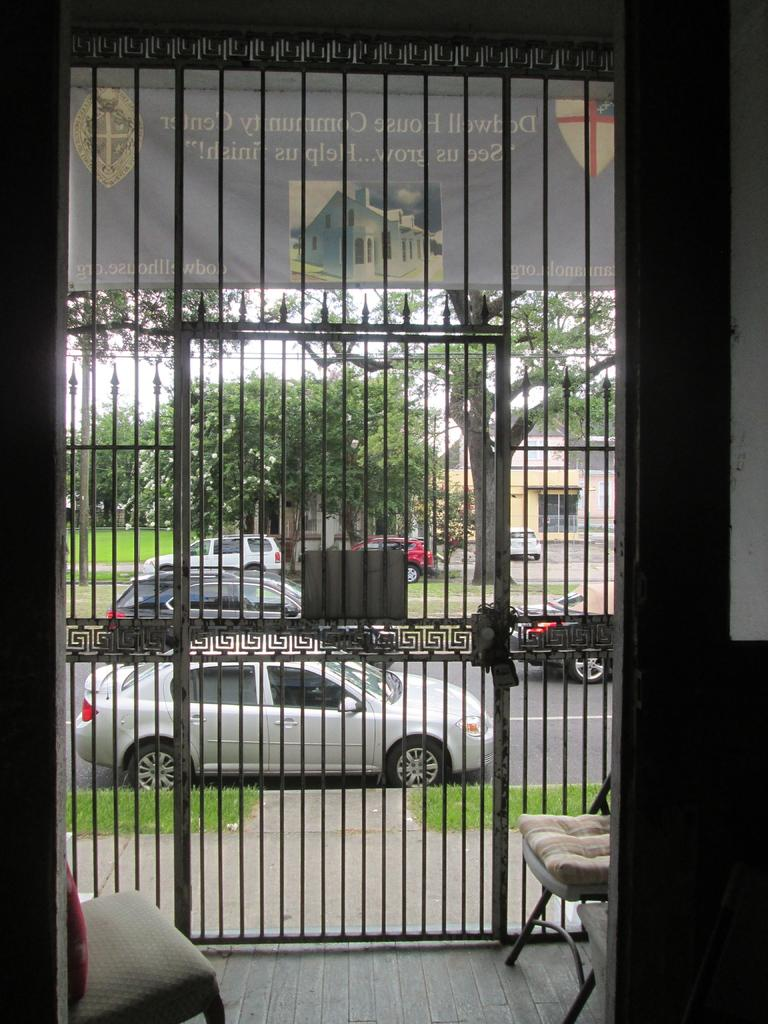What type of furniture can be seen on the floor in the image? There are chairs on the floor in the image. What structure is present in the image that might control access? There is a gate in the image. What type of signage is visible in the image? There is a banner in the image. What type of transportation can be seen in the image? There are vehicles on the road in the image. What type of natural vegetation is present in the image? There is grass and trees in the image. What type of building is present in the image? There is a shed in the image. Can you describe any unspecified objects in the image? There are some unspecified objects in the image. What can be seen in the background of the image? The sky is visible in the background of the image. Can you tell me how many friends are visible in the image? There is no mention of friends in the image; it features chairs, a gate, a banner, vehicles, grass, trees, a shed, and some unspecified objects. Was there an earthquake in the area depicted in the image? There is no indication of an earthquake in the image; it shows a relatively calm scene with chairs, a gate, a banner, vehicles, grass, trees, a shed, and some unspecified objects. 